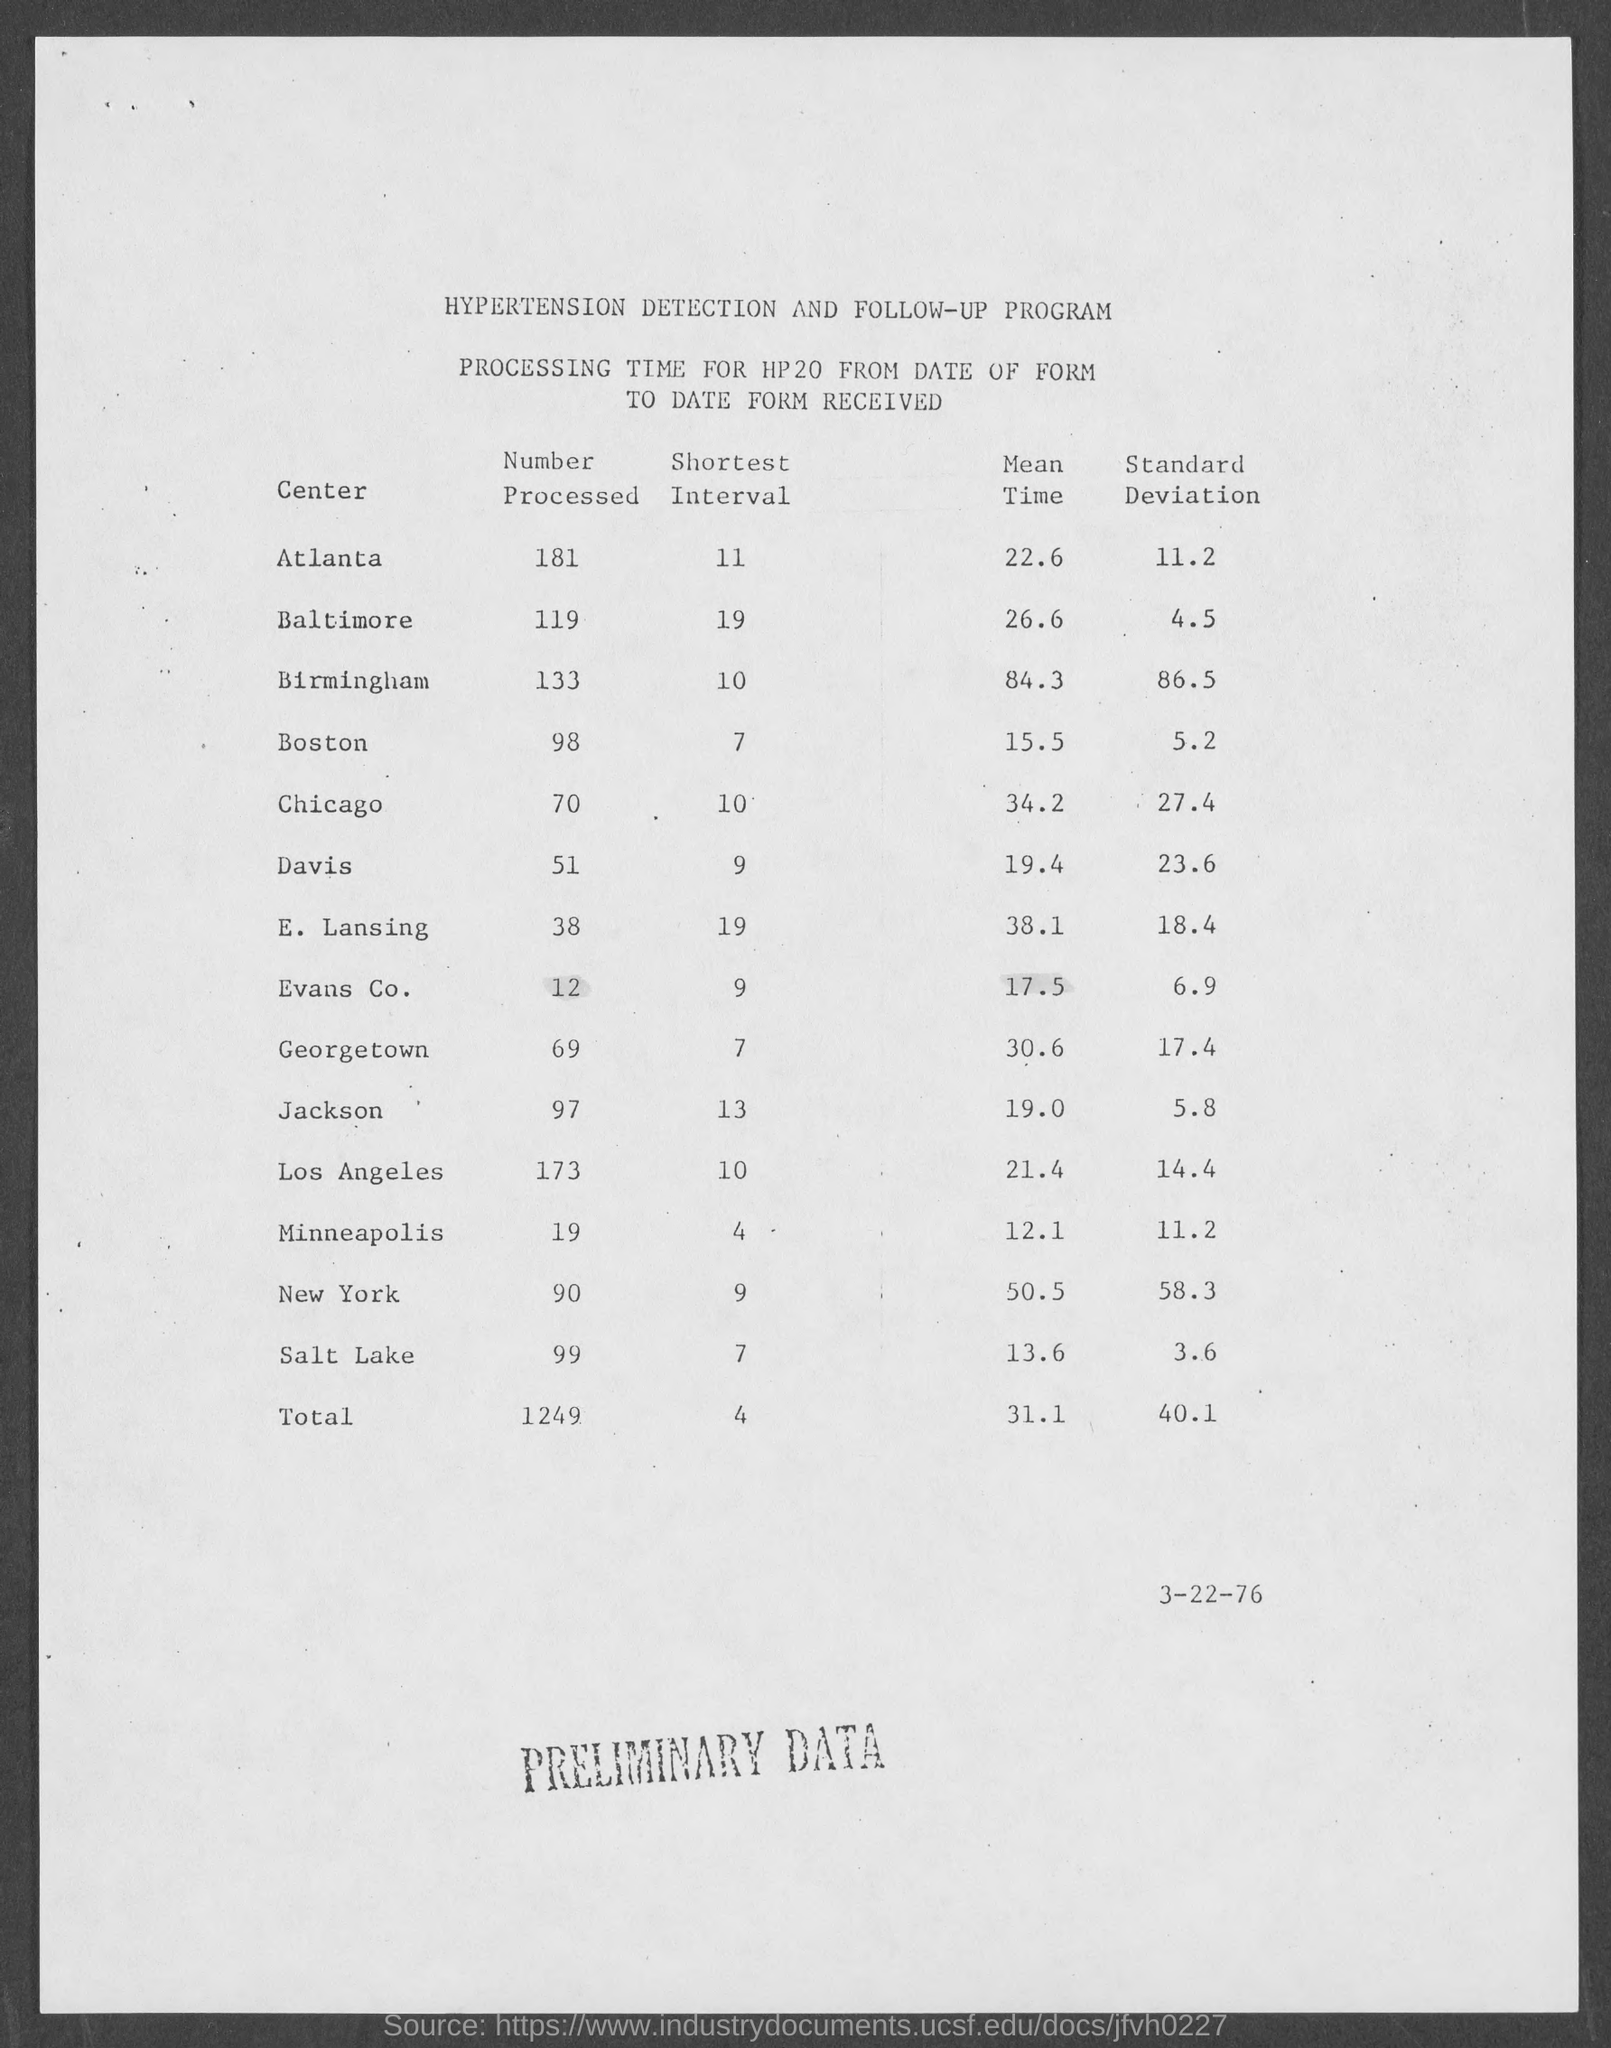What is the name of the program?
Your answer should be very brief. Hypertension Detection and Follow-up Program. What is the shortest interval for atlanta?
Provide a short and direct response. 11. What is number processed for atlanta?
Provide a short and direct response. 181. What is mean time for atlanta?
Your answer should be compact. 22.6. What is standard deviation for atlanta?
Your answer should be compact. 11.2. What is number processed for baltimore?
Your answer should be compact. 119. What is shortest interval for baltimore?
Give a very brief answer. 19. What is the meantime for baltimore?
Ensure brevity in your answer.  26.6. What is standard deviation for baltimore?
Your answer should be compact. 4.5. What is number processed for birmingham?
Your answer should be compact. 133. 